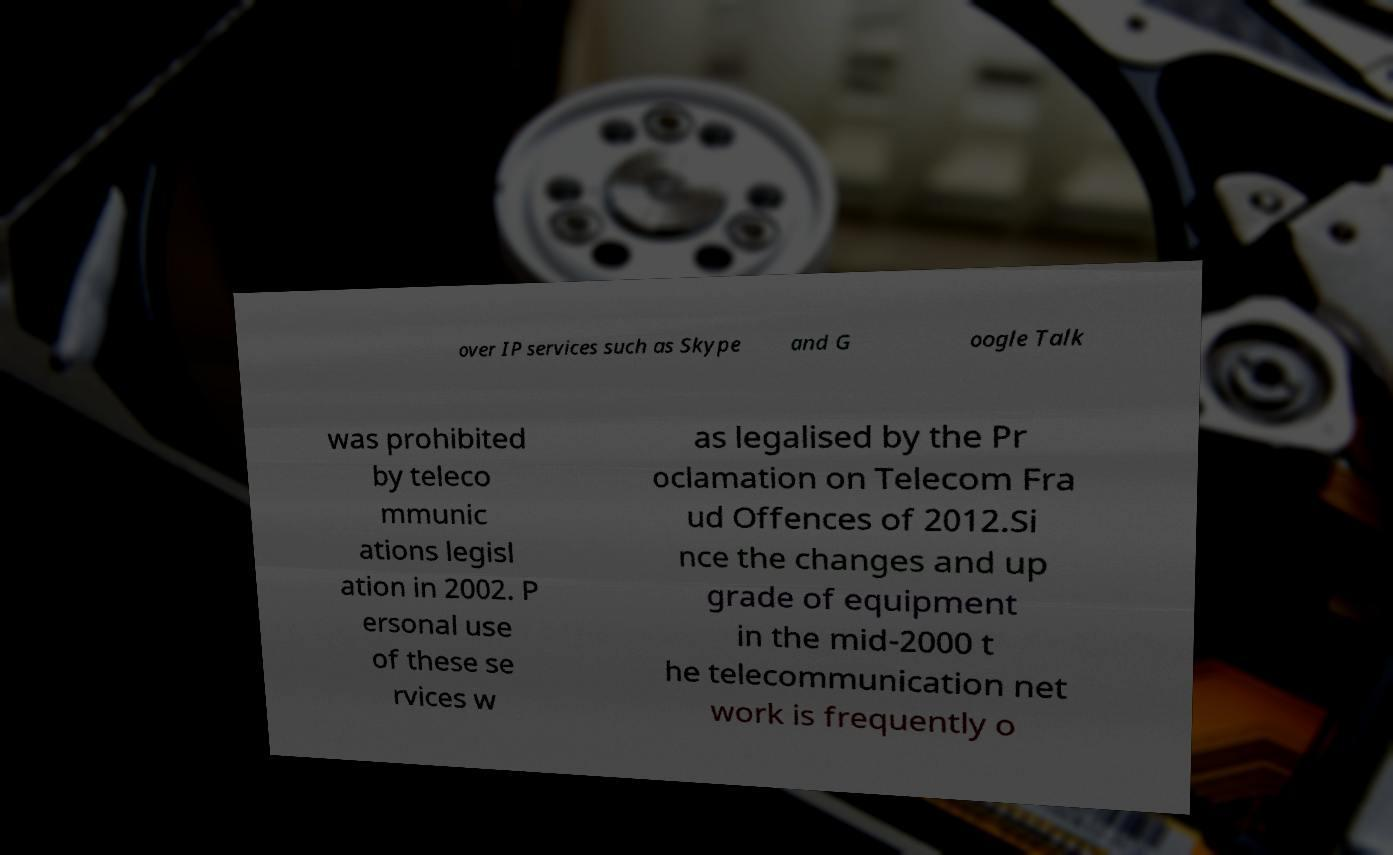Can you accurately transcribe the text from the provided image for me? over IP services such as Skype and G oogle Talk was prohibited by teleco mmunic ations legisl ation in 2002. P ersonal use of these se rvices w as legalised by the Pr oclamation on Telecom Fra ud Offences of 2012.Si nce the changes and up grade of equipment in the mid-2000 t he telecommunication net work is frequently o 